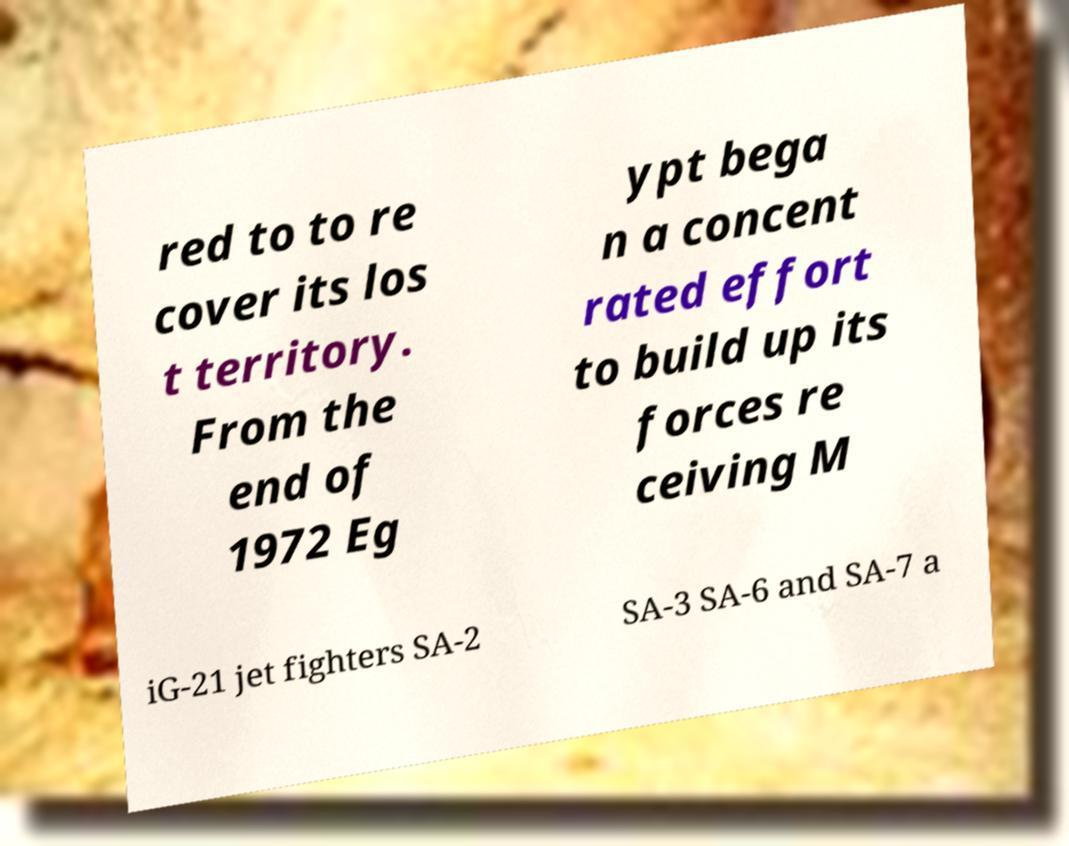Please identify and transcribe the text found in this image. red to to re cover its los t territory. From the end of 1972 Eg ypt bega n a concent rated effort to build up its forces re ceiving M iG-21 jet fighters SA-2 SA-3 SA-6 and SA-7 a 